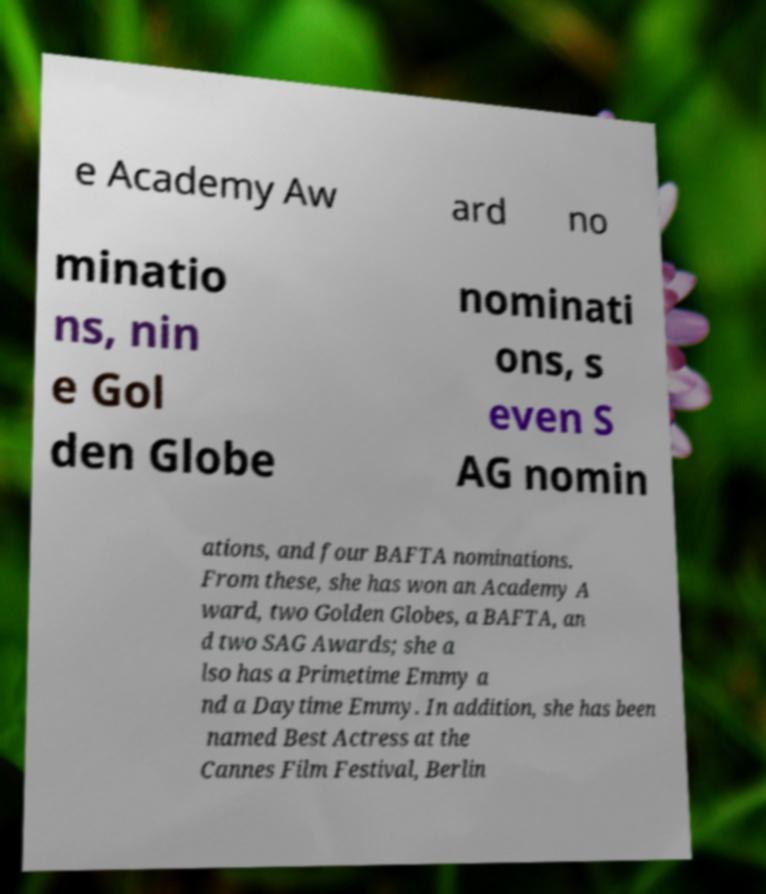I need the written content from this picture converted into text. Can you do that? e Academy Aw ard no minatio ns, nin e Gol den Globe nominati ons, s even S AG nomin ations, and four BAFTA nominations. From these, she has won an Academy A ward, two Golden Globes, a BAFTA, an d two SAG Awards; she a lso has a Primetime Emmy a nd a Daytime Emmy. In addition, she has been named Best Actress at the Cannes Film Festival, Berlin 